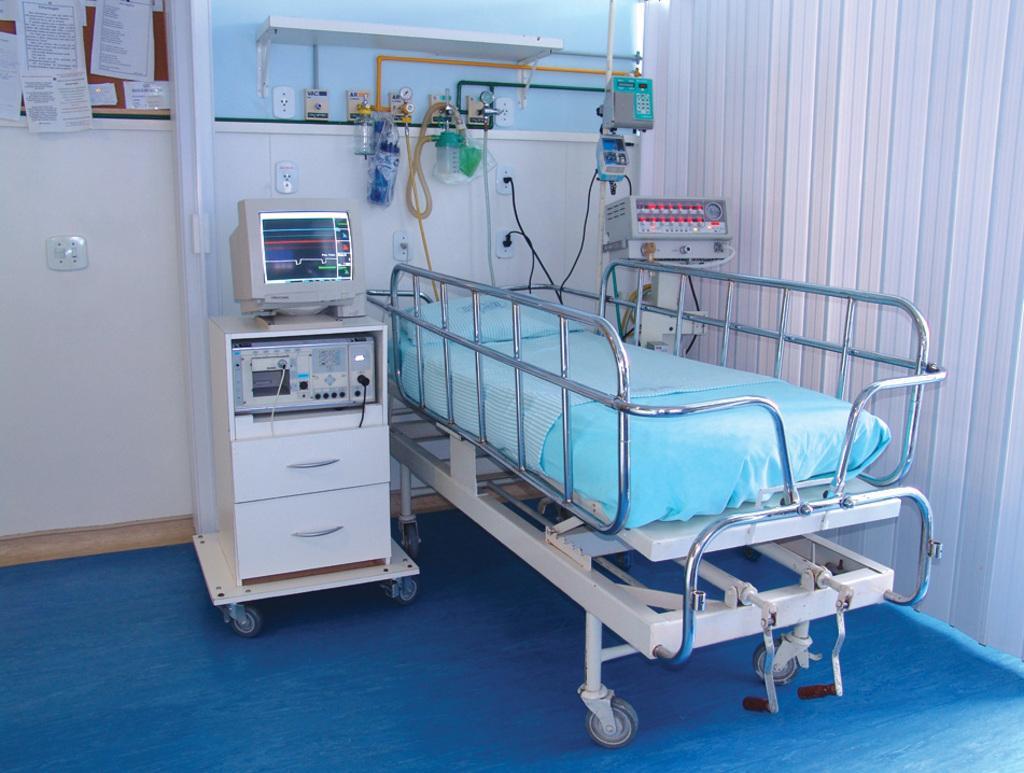How would you summarize this image in a sentence or two? In this picture we can see a bed and few metal rods, beside to the bed we can find a monitor and few medical equipments, and also we can see window blinds. 